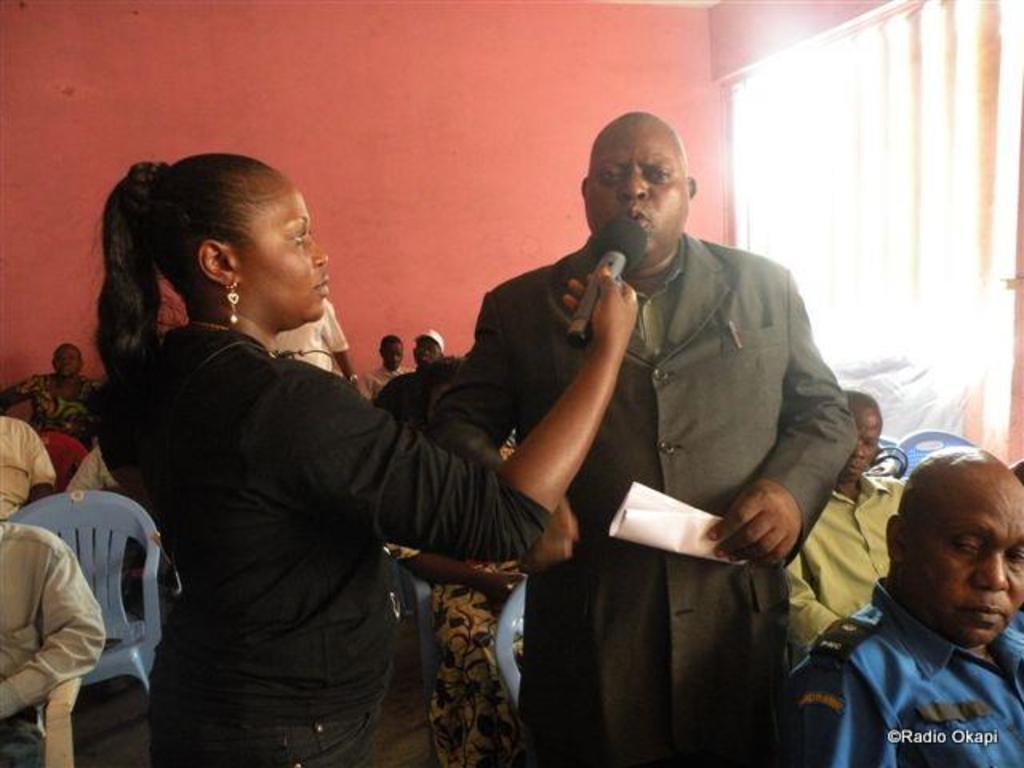Could you give a brief overview of what you see in this image? In the middle of the image few persons standing and she is holding a microphone and he is holding a paper. Behind them few people are sitting. At the top of the image there is wall, on the wall there is a window. 